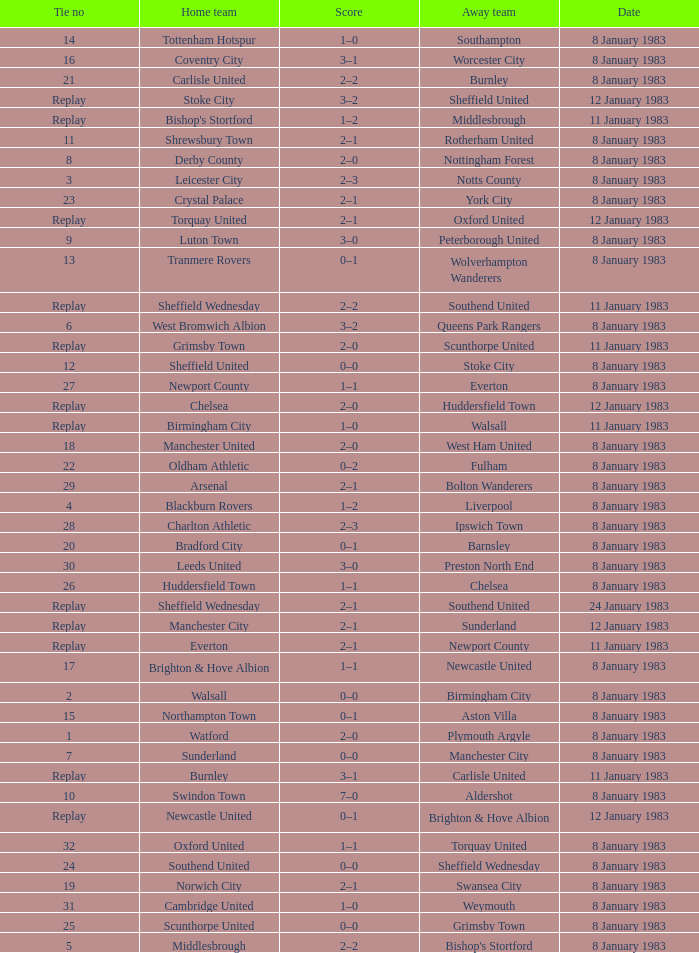What is the name of the away team for Tie #19? Swansea City. 